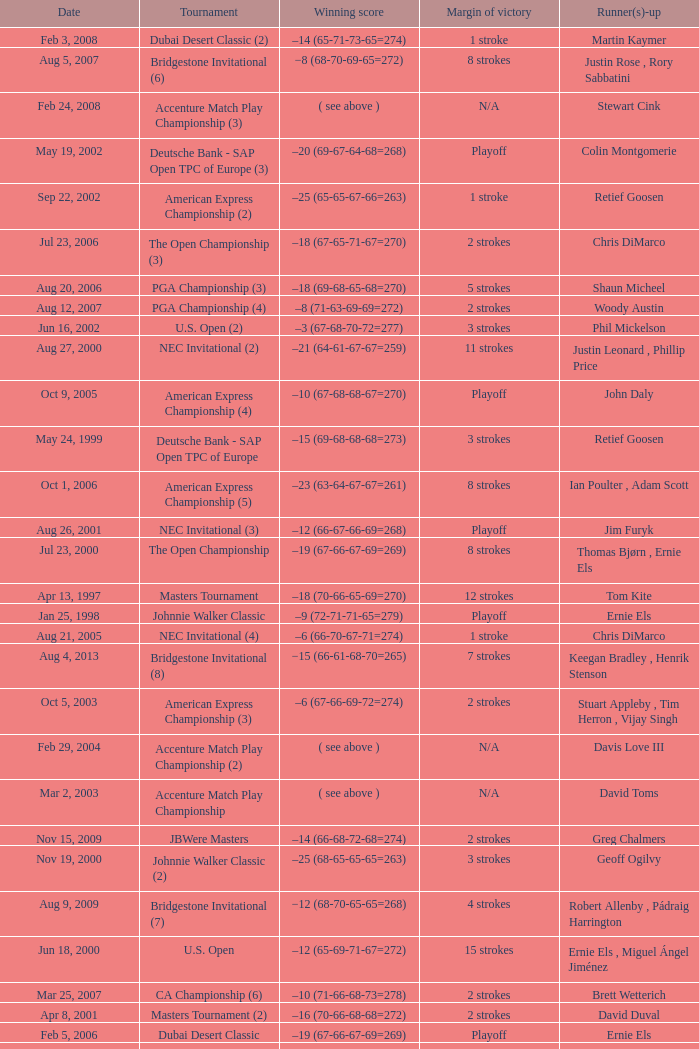Who is Runner(s)-up that has a Date of may 24, 1999? Retief Goosen. 